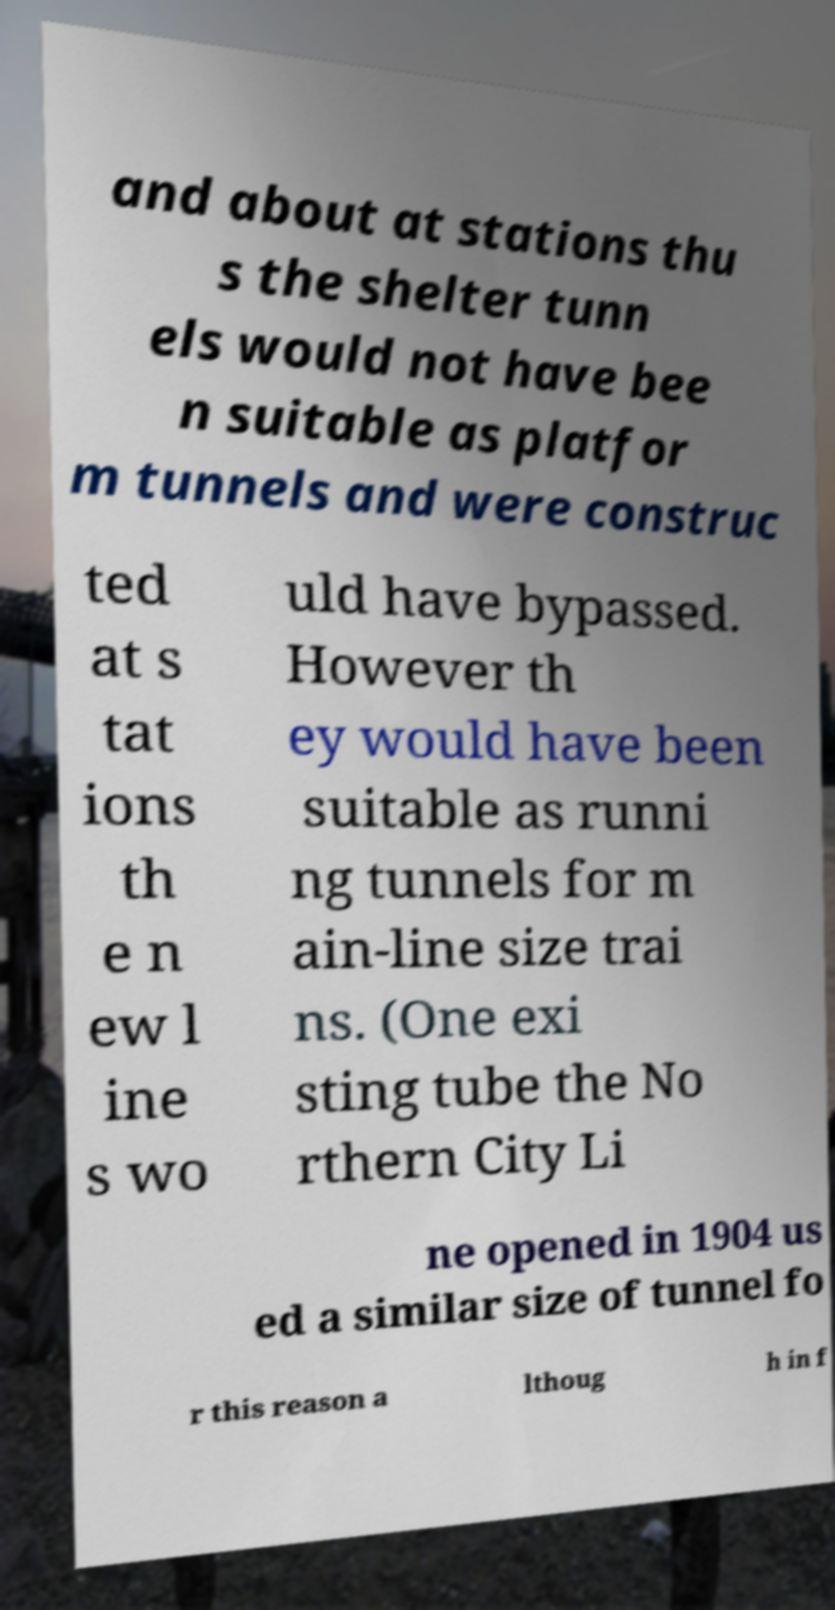For documentation purposes, I need the text within this image transcribed. Could you provide that? and about at stations thu s the shelter tunn els would not have bee n suitable as platfor m tunnels and were construc ted at s tat ions th e n ew l ine s wo uld have bypassed. However th ey would have been suitable as runni ng tunnels for m ain-line size trai ns. (One exi sting tube the No rthern City Li ne opened in 1904 us ed a similar size of tunnel fo r this reason a lthoug h in f 